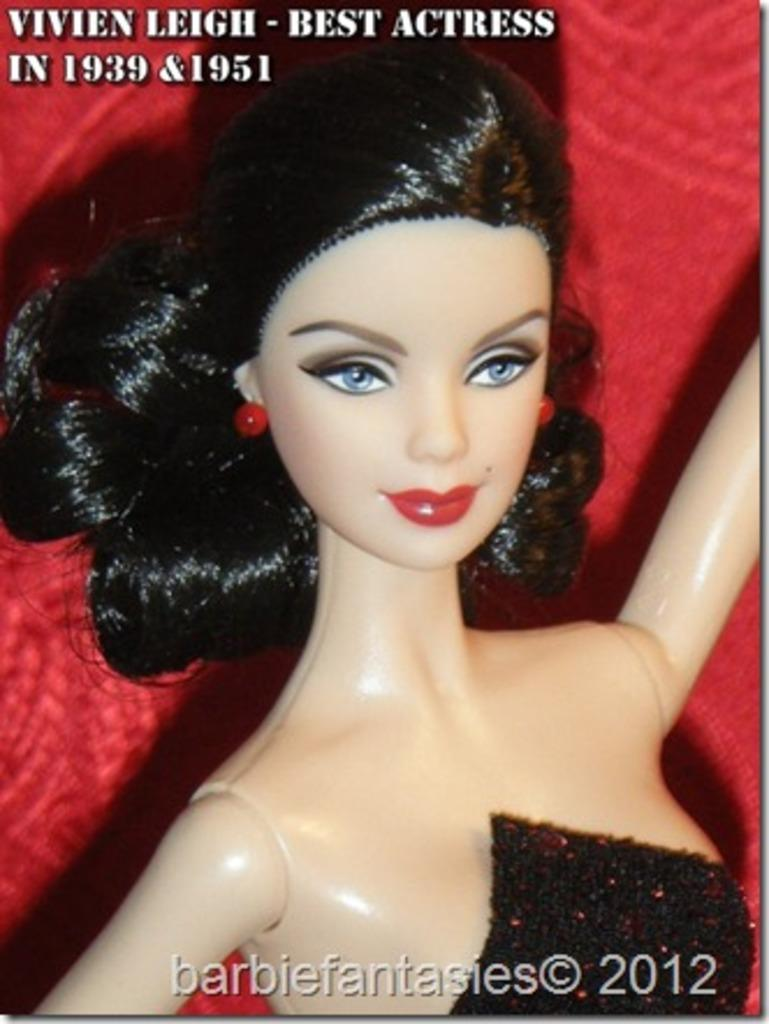Who is present in the image? There is a woman in the image. What can be seen in the background of the image? The background of the image is red. Is the woman stuck in quicksand in the image? There is no quicksand present in the image, and the woman is not shown to be stuck in any substance. 